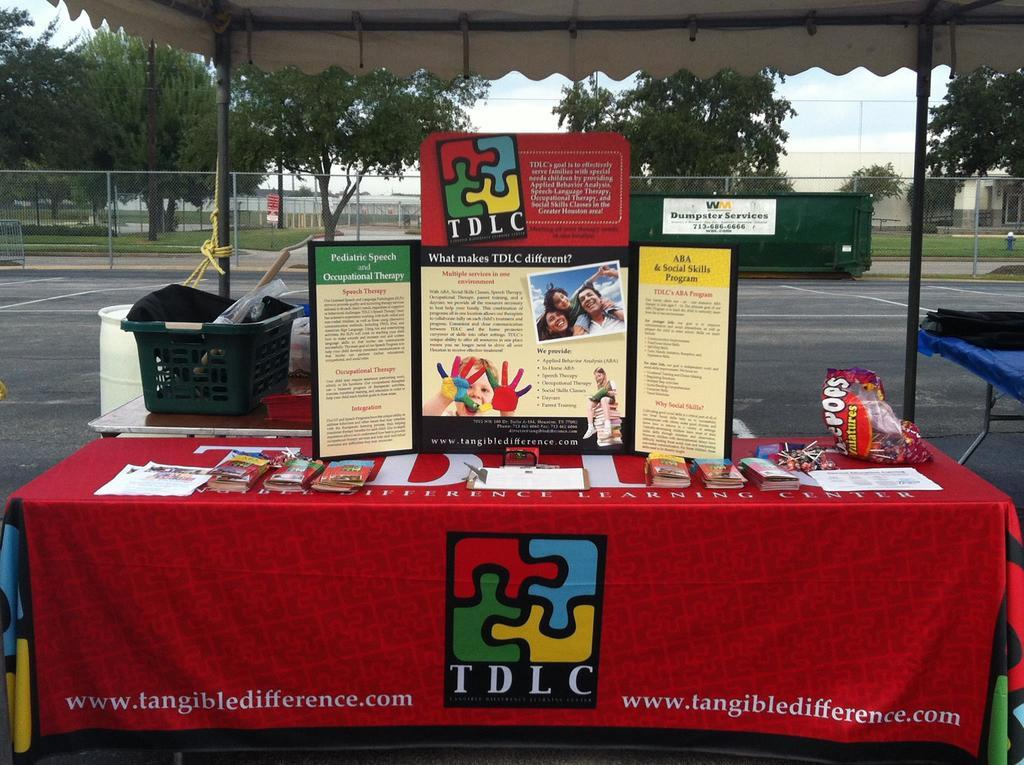Provide a one-sentence caption for the provided image. A table is set up in a parking lot for information about TDLC program. 